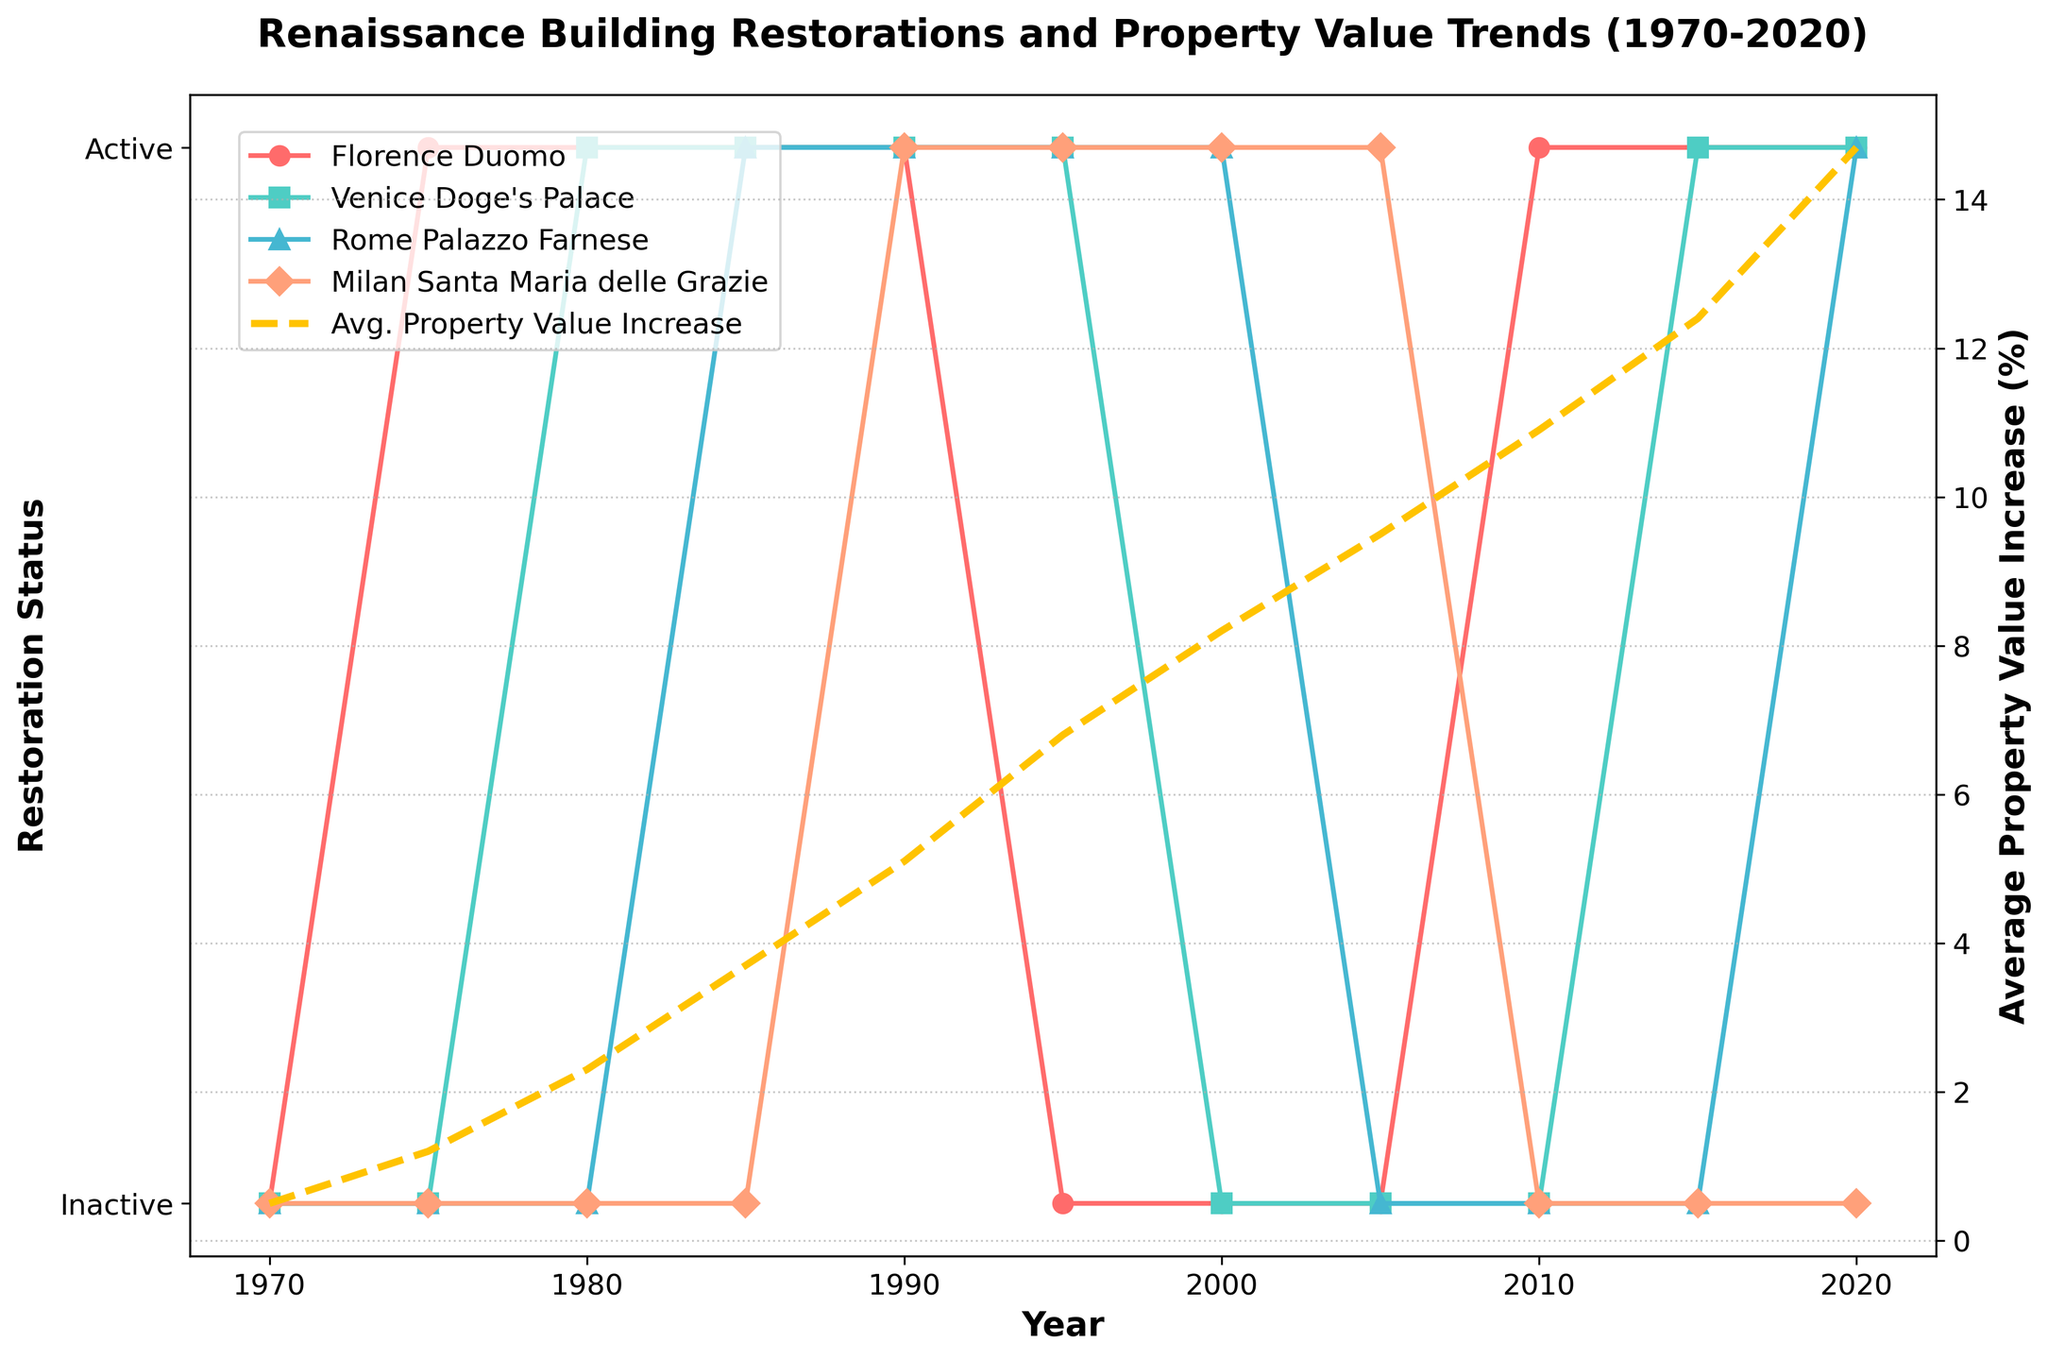What's the trend in the Florence Duomo Restoration status between 1970 and 2020? The trend for the Florence Duomo Restoration shows that it was inactive until 1975 and then alternated between being active and inactive, with the latest periods of activity in 2010 and 2020.
Answer: Alternating with recent activity How many years was the Rome Palazzo Farnese Restoration active between 1970 and 2020? By analyzing the chart, the Rome Palazzo Farnese Restoration was active in the years 1985, 1990, 1995, 2000, and 2020. Adding these up gives 5 years.
Answer: 5 years Which restoration was the most consistently active from 1970 to 2020? Venice Doge's Palace Restoration was active in 7 out of the 11 recorded years, making it the most consistently active restoration in the chart.
Answer: Venice Doge's Palace Restoration Between which years did the average property value increase show the highest increment? The highest increase in average property value (%) occurs between 1975 and 1985, jumping from 1.2% to 3.7%, an increment of 2.5%.
Answer: 1975 to 1985 Did any restoration projects coincide with an increase in average property value from 2005 to 2015? In the years 2010 and 2015, Florence Duomo Restoration and Venice Doge's Palace Restoration were active. During this period, the average property value increased from 9.5% to 12.4%.
Answer: Yes, Florence Duomo Restoration and Venice Doge's Palace Restoration How many restorations were simultaneously active in 1990, and what was the average property value increase that year? In 1990, Florence Duomo Restoration, Venice Doge's Palace Restoration, Rome Palazzo Farnese Restoration, and Milan Santa Maria delle Grazie Restoration were all active. The average property value increase that year was 5.1%.
Answer: 4 restorations; 5.1% Which years show a restoration status change for the Milan Santa Maria delle Grazie, and what was the average property value increase in the subsequent year? Milan Santa Maria delle Grazie Restoration shows status changes in 1990, 1995, and 2005. The subsequent years 1991, 1996, and 2006 had average property value increases of 5.1%, 6.8%, and 9.5%, respectively.
Answer: 1990, 1995, 2005; 5.1%, 6.8%, 9.5% Are there any years when all four restoration projects were inactive? According to the chart, years where all four restoration projects were inactive are 1970, 1980, 2000, and 2005.
Answer: 1970, 1980, 2000, 2005 What is the difference in average property value increase (%) between the years 1980 and 2020? In 1980, the average property value increase was 2.3%, whereas in 2020, it was 14.7%. The difference is 14.7% - 2.3% = 12.4%.
Answer: 12.4% What colors represent the Venice Doge's Palace Restoration and average property value increase? The Venice Doge's Palace Restoration is represented in green while the average property value increase is in yellow.
Answer: Green; Yellow 